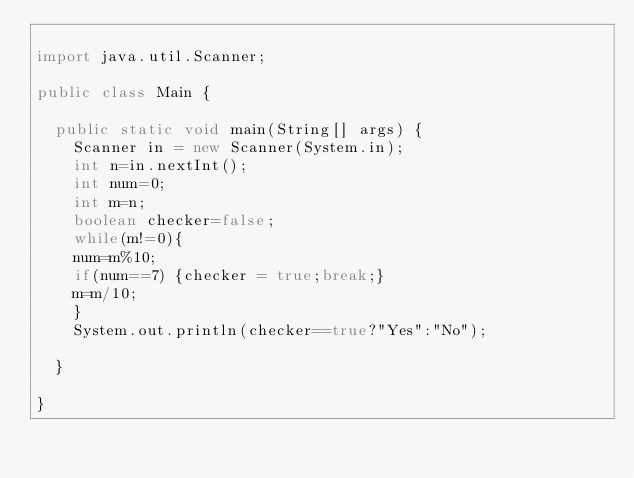<code> <loc_0><loc_0><loc_500><loc_500><_Java_>
import java.util.Scanner;

public class Main {

	public static void main(String[] args) {
		Scanner in = new Scanner(System.in);
		int n=in.nextInt();
		int num=0;
		int m=n;
		boolean checker=false;
		while(m!=0){
		num=m%10;
		if(num==7) {checker = true;break;}
		m=m/10;
		}
		System.out.println(checker==true?"Yes":"No");

	}

}
</code> 